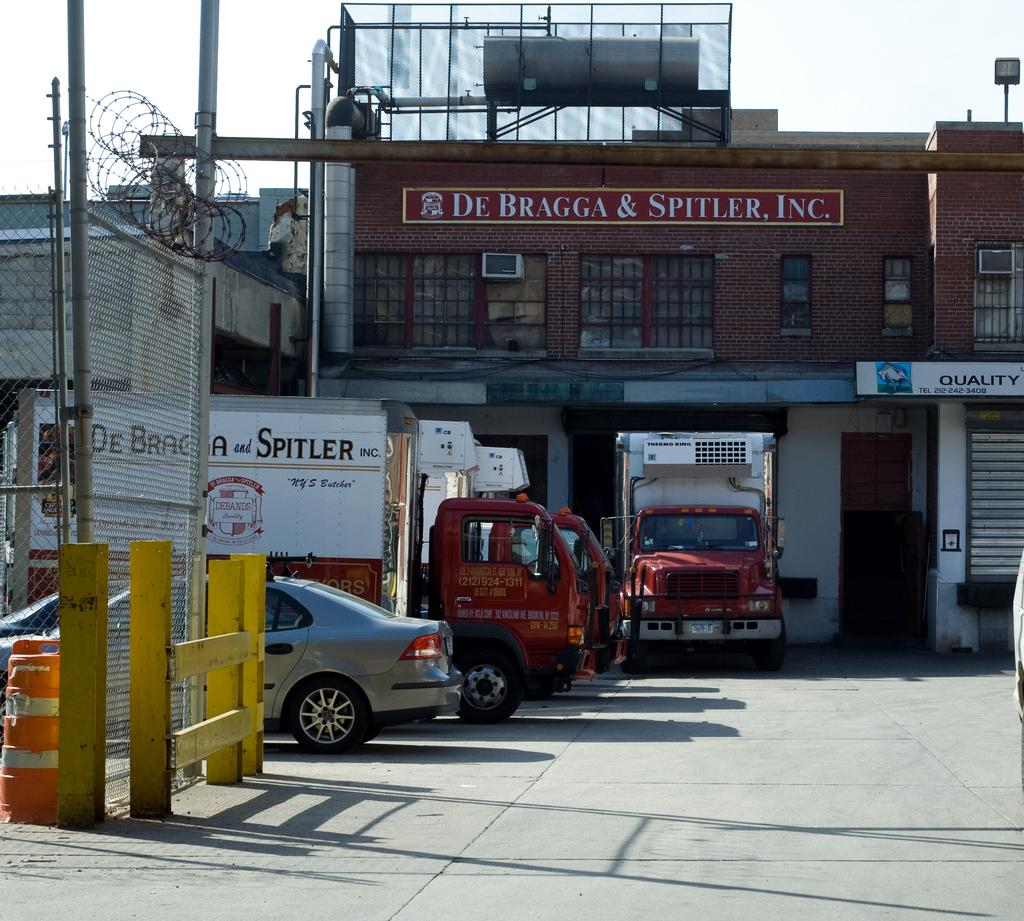Provide a one-sentence caption for the provided image. The butcher company De Bragga & Spitler, Inc. has their own delivery trucks. 